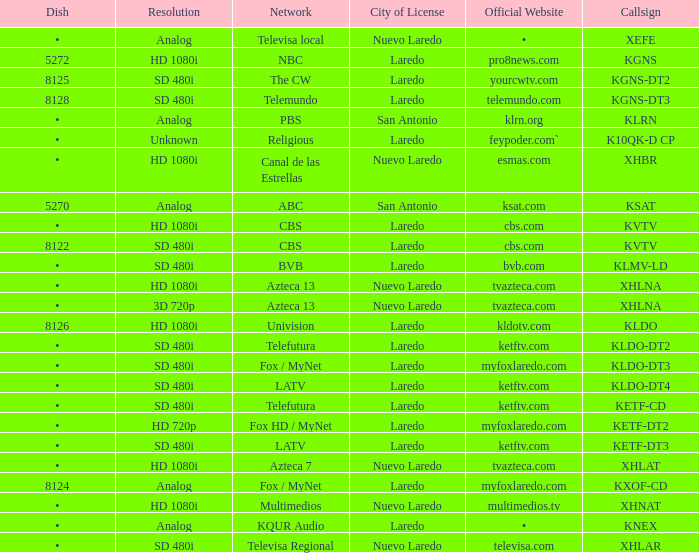Name the resolution for dish of 5270 Analog. 